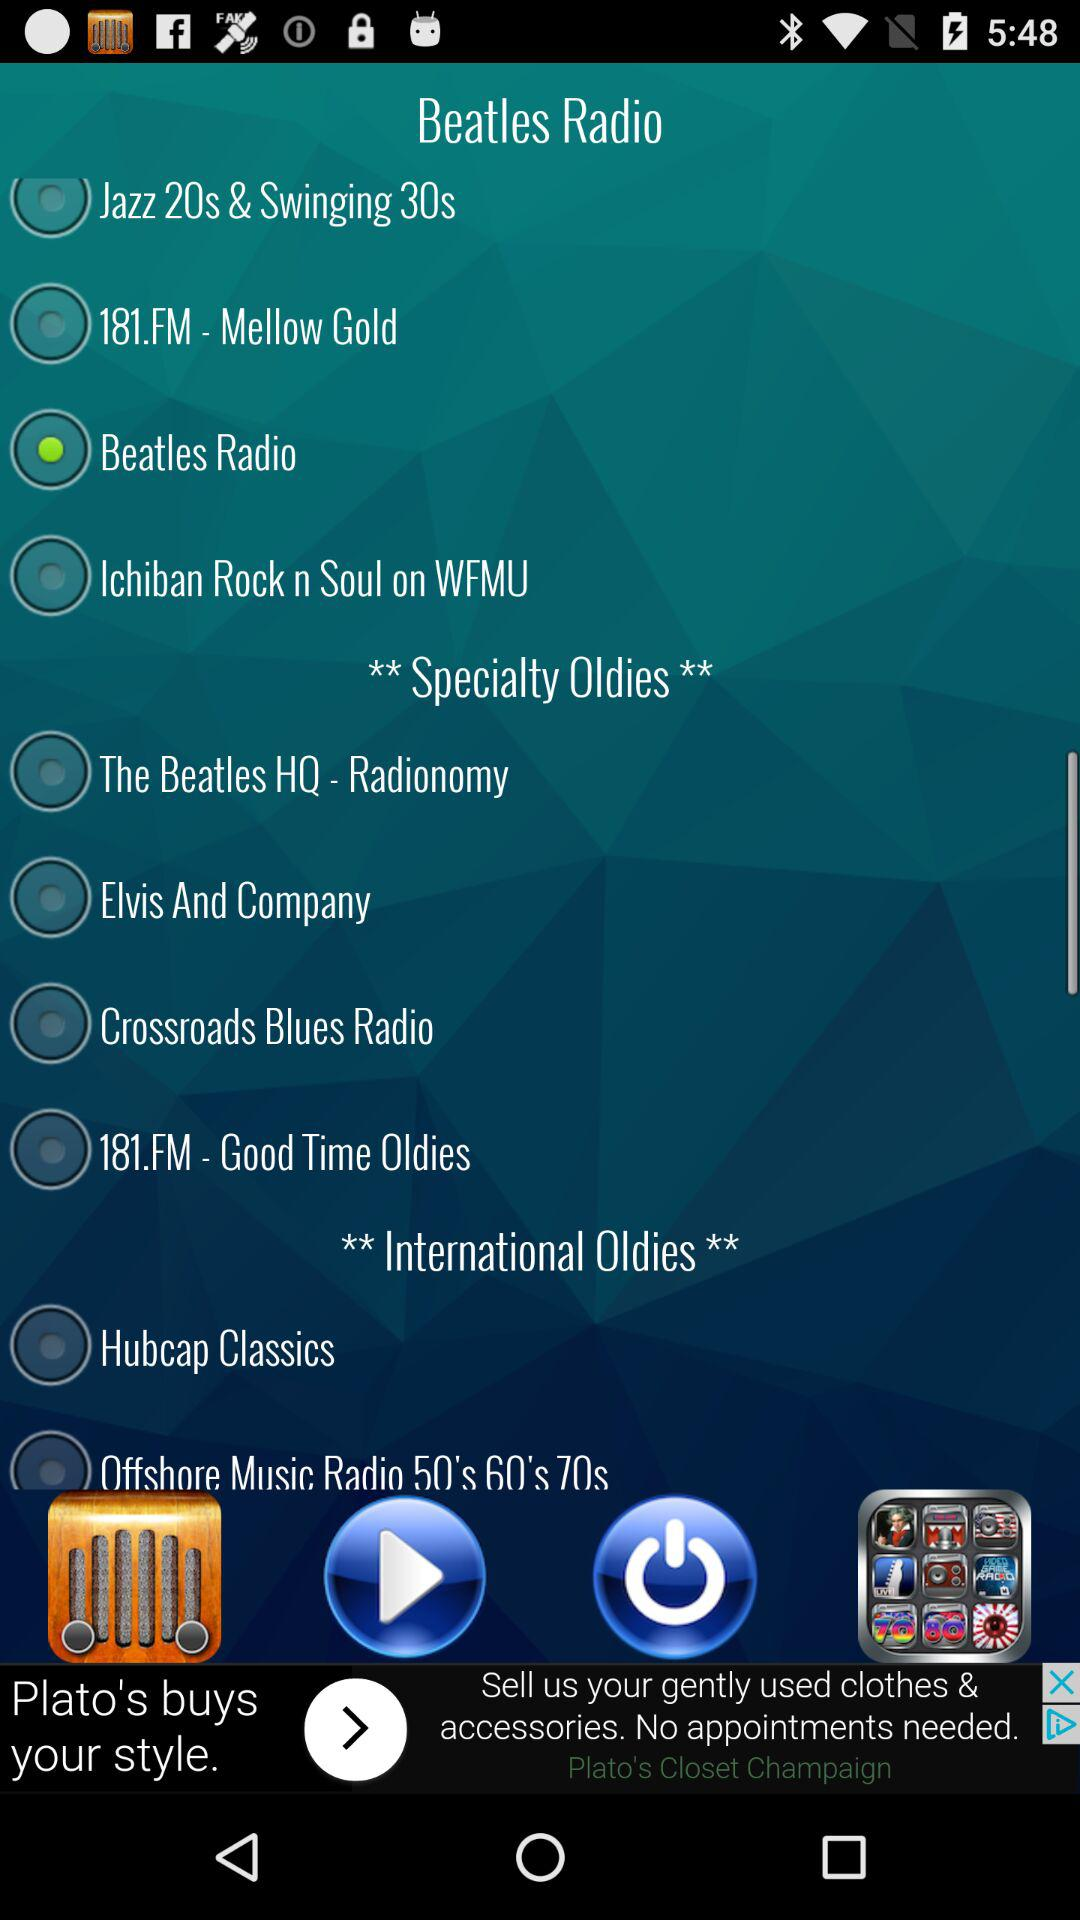Is "Elvis And Company" currently selected or not? "Elvis And Company" is currently not selected. 